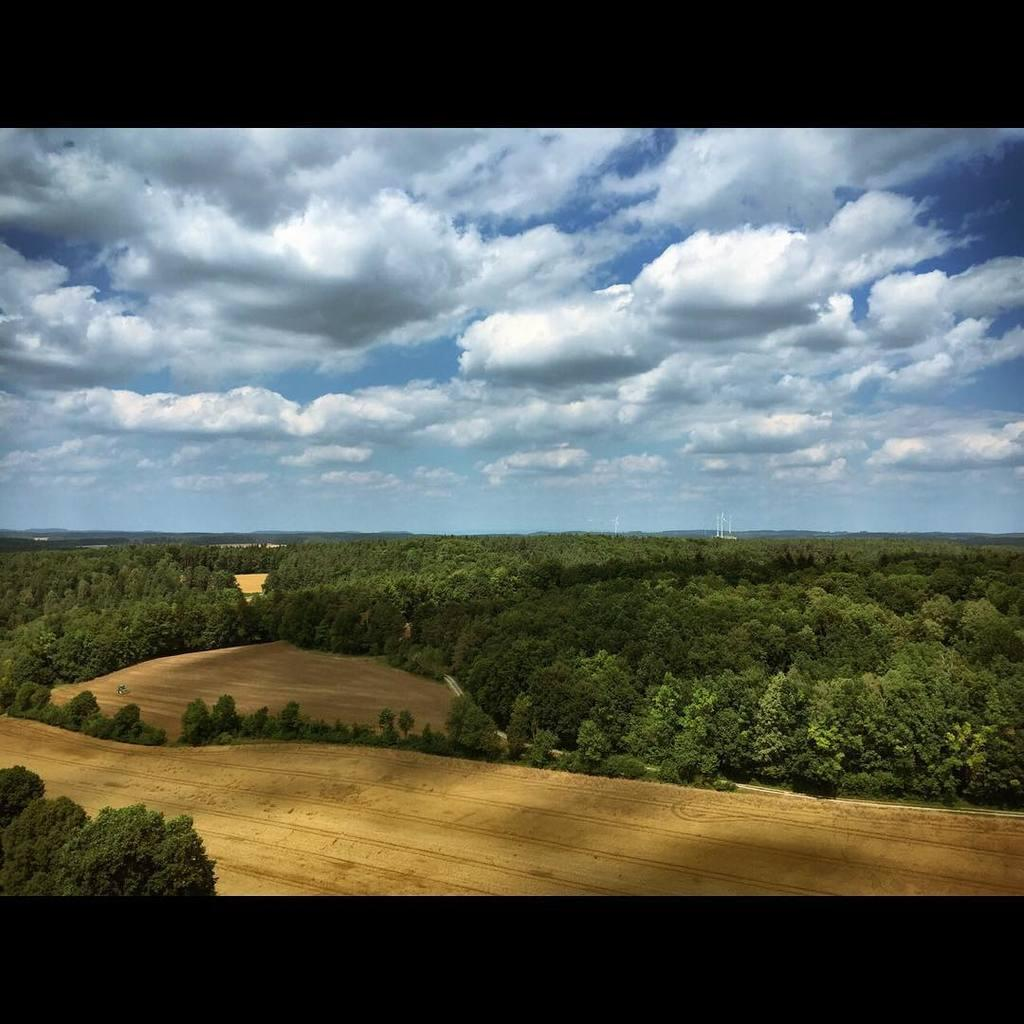What type of vegetation is present on the ground in the image? There is a group of trees on the ground in the image. What else can be seen in the background of the image? There are poles visible in the background of the image. What is visible above the trees and poles in the image? The sky is visible in the image. How would you describe the weather based on the appearance of the sky? The sky appears to be cloudy in the image. What type of oven can be seen in the image? There is no oven present in the image. Is there any popcorn visible in the image? There is no popcorn present in the image. 